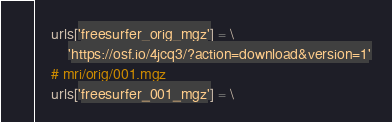Convert code to text. <code><loc_0><loc_0><loc_500><loc_500><_Python_>    urls['freesurfer_orig_mgz'] = \
        'https://osf.io/4jcq3/?action=download&version=1'
    # mri/orig/001.mgz
    urls['freesurfer_001_mgz'] = \</code> 